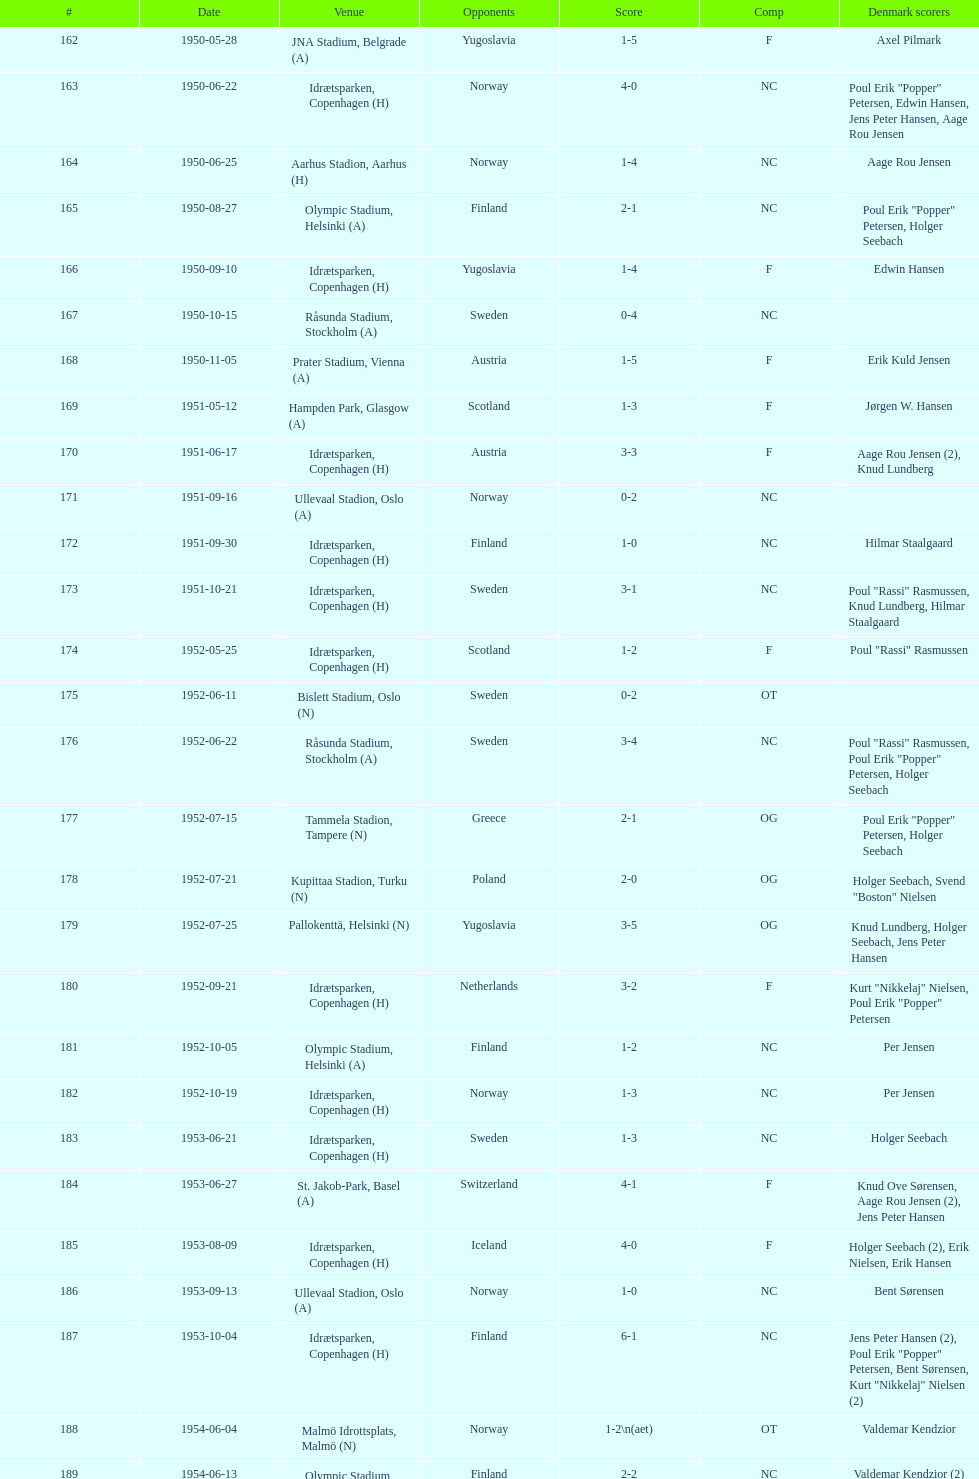Help me parse the entirety of this table. {'header': ['#', 'Date', 'Venue', 'Opponents', 'Score', 'Comp', 'Denmark scorers'], 'rows': [['162', '1950-05-28', 'JNA Stadium, Belgrade (A)', 'Yugoslavia', '1-5', 'F', 'Axel Pilmark'], ['163', '1950-06-22', 'Idrætsparken, Copenhagen (H)', 'Norway', '4-0', 'NC', 'Poul Erik "Popper" Petersen, Edwin Hansen, Jens Peter Hansen, Aage Rou Jensen'], ['164', '1950-06-25', 'Aarhus Stadion, Aarhus (H)', 'Norway', '1-4', 'NC', 'Aage Rou Jensen'], ['165', '1950-08-27', 'Olympic Stadium, Helsinki (A)', 'Finland', '2-1', 'NC', 'Poul Erik "Popper" Petersen, Holger Seebach'], ['166', '1950-09-10', 'Idrætsparken, Copenhagen (H)', 'Yugoslavia', '1-4', 'F', 'Edwin Hansen'], ['167', '1950-10-15', 'Råsunda Stadium, Stockholm (A)', 'Sweden', '0-4', 'NC', ''], ['168', '1950-11-05', 'Prater Stadium, Vienna (A)', 'Austria', '1-5', 'F', 'Erik Kuld Jensen'], ['169', '1951-05-12', 'Hampden Park, Glasgow (A)', 'Scotland', '1-3', 'F', 'Jørgen W. Hansen'], ['170', '1951-06-17', 'Idrætsparken, Copenhagen (H)', 'Austria', '3-3', 'F', 'Aage Rou Jensen (2), Knud Lundberg'], ['171', '1951-09-16', 'Ullevaal Stadion, Oslo (A)', 'Norway', '0-2', 'NC', ''], ['172', '1951-09-30', 'Idrætsparken, Copenhagen (H)', 'Finland', '1-0', 'NC', 'Hilmar Staalgaard'], ['173', '1951-10-21', 'Idrætsparken, Copenhagen (H)', 'Sweden', '3-1', 'NC', 'Poul "Rassi" Rasmussen, Knud Lundberg, Hilmar Staalgaard'], ['174', '1952-05-25', 'Idrætsparken, Copenhagen (H)', 'Scotland', '1-2', 'F', 'Poul "Rassi" Rasmussen'], ['175', '1952-06-11', 'Bislett Stadium, Oslo (N)', 'Sweden', '0-2', 'OT', ''], ['176', '1952-06-22', 'Råsunda Stadium, Stockholm (A)', 'Sweden', '3-4', 'NC', 'Poul "Rassi" Rasmussen, Poul Erik "Popper" Petersen, Holger Seebach'], ['177', '1952-07-15', 'Tammela Stadion, Tampere (N)', 'Greece', '2-1', 'OG', 'Poul Erik "Popper" Petersen, Holger Seebach'], ['178', '1952-07-21', 'Kupittaa Stadion, Turku (N)', 'Poland', '2-0', 'OG', 'Holger Seebach, Svend "Boston" Nielsen'], ['179', '1952-07-25', 'Pallokenttä, Helsinki (N)', 'Yugoslavia', '3-5', 'OG', 'Knud Lundberg, Holger Seebach, Jens Peter Hansen'], ['180', '1952-09-21', 'Idrætsparken, Copenhagen (H)', 'Netherlands', '3-2', 'F', 'Kurt "Nikkelaj" Nielsen, Poul Erik "Popper" Petersen'], ['181', '1952-10-05', 'Olympic Stadium, Helsinki (A)', 'Finland', '1-2', 'NC', 'Per Jensen'], ['182', '1952-10-19', 'Idrætsparken, Copenhagen (H)', 'Norway', '1-3', 'NC', 'Per Jensen'], ['183', '1953-06-21', 'Idrætsparken, Copenhagen (H)', 'Sweden', '1-3', 'NC', 'Holger Seebach'], ['184', '1953-06-27', 'St. Jakob-Park, Basel (A)', 'Switzerland', '4-1', 'F', 'Knud Ove Sørensen, Aage Rou Jensen (2), Jens Peter Hansen'], ['185', '1953-08-09', 'Idrætsparken, Copenhagen (H)', 'Iceland', '4-0', 'F', 'Holger Seebach (2), Erik Nielsen, Erik Hansen'], ['186', '1953-09-13', 'Ullevaal Stadion, Oslo (A)', 'Norway', '1-0', 'NC', 'Bent Sørensen'], ['187', '1953-10-04', 'Idrætsparken, Copenhagen (H)', 'Finland', '6-1', 'NC', 'Jens Peter Hansen (2), Poul Erik "Popper" Petersen, Bent Sørensen, Kurt "Nikkelaj" Nielsen (2)'], ['188', '1954-06-04', 'Malmö Idrottsplats, Malmö (N)', 'Norway', '1-2\\n(aet)', 'OT', 'Valdemar Kendzior'], ['189', '1954-06-13', 'Olympic Stadium, Helsinki (A)', 'Finland', '2-2', 'NC', 'Valdemar Kendzior (2)'], ['190', '1954-09-19', 'Idrætsparken, Copenhagen (H)', 'Switzerland', '1-1', 'F', 'Jørgen Olesen'], ['191', '1954-10-10', 'Råsunda Stadium, Stockholm (A)', 'Sweden', '2-5', 'NC', 'Jens Peter Hansen, Bent Sørensen'], ['192', '1954-10-31', 'Idrætsparken, Copenhagen (H)', 'Norway', '0-1', 'NC', ''], ['193', '1955-03-13', 'Olympic Stadium, Amsterdam (A)', 'Netherlands', '1-1', 'F', 'Vagn Birkeland'], ['194', '1955-05-15', 'Idrætsparken, Copenhagen (H)', 'Hungary', '0-6', 'F', ''], ['195', '1955-06-19', 'Idrætsparken, Copenhagen (H)', 'Finland', '2-1', 'NC', 'Jens Peter Hansen (2)'], ['196', '1955-06-03', 'Melavollur, Reykjavík (A)', 'Iceland', '4-0', 'F', 'Aage Rou Jensen, Jens Peter Hansen, Poul Pedersen (2)'], ['197', '1955-09-11', 'Ullevaal Stadion, Oslo (A)', 'Norway', '1-1', 'NC', 'Jørgen Jacobsen'], ['198', '1955-10-02', 'Idrætsparken, Copenhagen (H)', 'England', '1-5', 'NC', 'Knud Lundberg'], ['199', '1955-10-16', 'Idrætsparken, Copenhagen (H)', 'Sweden', '3-3', 'NC', 'Ove Andersen (2), Knud Lundberg'], ['200', '1956-05-23', 'Dynamo Stadium, Moscow (A)', 'USSR', '1-5', 'F', 'Knud Lundberg'], ['201', '1956-06-24', 'Idrætsparken, Copenhagen (H)', 'Norway', '2-3', 'NC', 'Knud Lundberg, Poul Pedersen'], ['202', '1956-07-01', 'Idrætsparken, Copenhagen (H)', 'USSR', '2-5', 'F', 'Ove Andersen, Aage Rou Jensen'], ['203', '1956-09-16', 'Olympic Stadium, Helsinki (A)', 'Finland', '4-0', 'NC', 'Poul Pedersen, Jørgen Hansen, Ove Andersen (2)'], ['204', '1956-10-03', 'Dalymount Park, Dublin (A)', 'Republic of Ireland', '1-2', 'WCQ', 'Aage Rou Jensen'], ['205', '1956-10-21', 'Råsunda Stadium, Stockholm (A)', 'Sweden', '1-1', 'NC', 'Jens Peter Hansen'], ['206', '1956-11-04', 'Idrætsparken, Copenhagen (H)', 'Netherlands', '2-2', 'F', 'Jørgen Olesen, Knud Lundberg'], ['207', '1956-12-05', 'Molineux, Wolverhampton (A)', 'England', '2-5', 'WCQ', 'Ove Bech Nielsen (2)'], ['208', '1957-05-15', 'Idrætsparken, Copenhagen (H)', 'England', '1-4', 'WCQ', 'John Jensen'], ['209', '1957-05-26', 'Idrætsparken, Copenhagen (H)', 'Bulgaria', '1-1', 'F', 'Aage Rou Jensen'], ['210', '1957-06-18', 'Olympic Stadium, Helsinki (A)', 'Finland', '0-2', 'OT', ''], ['211', '1957-06-19', 'Tammela Stadion, Tampere (N)', 'Norway', '2-0', 'OT', 'Egon Jensen, Jørgen Hansen'], ['212', '1957-06-30', 'Idrætsparken, Copenhagen (H)', 'Sweden', '1-2', 'NC', 'Jens Peter Hansen'], ['213', '1957-07-10', 'Laugardalsvöllur, Reykjavík (A)', 'Iceland', '6-2', 'OT', 'Egon Jensen (3), Poul Pedersen, Jens Peter Hansen (2)'], ['214', '1957-09-22', 'Ullevaal Stadion, Oslo (A)', 'Norway', '2-2', 'NC', 'Poul Pedersen, Peder Kjær'], ['215', '1957-10-02', 'Idrætsparken, Copenhagen (H)', 'Republic of Ireland', '0-2', 'WCQ', ''], ['216', '1957-10-13', 'Idrætsparken, Copenhagen (H)', 'Finland', '3-0', 'NC', 'Finn Alfred Hansen, Ove Bech Nielsen, Mogens Machon'], ['217', '1958-05-15', 'Aarhus Stadion, Aarhus (H)', 'Curaçao', '3-2', 'F', 'Poul Pedersen, Henning Enoksen (2)'], ['218', '1958-05-25', 'Idrætsparken, Copenhagen (H)', 'Poland', '3-2', 'F', 'Jørn Sørensen, Poul Pedersen (2)'], ['219', '1958-06-29', 'Idrætsparken, Copenhagen (H)', 'Norway', '1-2', 'NC', 'Poul Pedersen'], ['220', '1958-09-14', 'Olympic Stadium, Helsinki (A)', 'Finland', '4-1', 'NC', 'Poul Pedersen, Mogens Machon, John Danielsen (2)'], ['221', '1958-09-24', 'Idrætsparken, Copenhagen (H)', 'West Germany', '1-1', 'F', 'Henning Enoksen'], ['222', '1958-10-15', 'Idrætsparken, Copenhagen (H)', 'Netherlands', '1-5', 'F', 'Henning Enoksen'], ['223', '1958-10-26', 'Råsunda Stadium, Stockholm (A)', 'Sweden', '4-4', 'NC', 'Ole Madsen (2), Henning Enoksen, Jørn Sørensen'], ['224', '1959-06-21', 'Idrætsparken, Copenhagen (H)', 'Sweden', '0-6', 'NC', ''], ['225', '1959-06-26', 'Laugardalsvöllur, Reykjavík (A)', 'Iceland', '4-2', 'OGQ', 'Jens Peter Hansen (2), Ole Madsen (2)'], ['226', '1959-07-02', 'Idrætsparken, Copenhagen (H)', 'Norway', '2-1', 'OGQ', 'Henning Enoksen, Ole Madsen'], ['227', '1959-08-18', 'Idrætsparken, Copenhagen (H)', 'Iceland', '1-1', 'OGQ', 'Henning Enoksen'], ['228', '1959-09-13', 'Ullevaal Stadion, Oslo (A)', 'Norway', '4-2', 'OGQ\\nNC', 'Harald Nielsen, Henning Enoksen (2), Poul Pedersen'], ['229', '1959-09-23', 'Idrætsparken, Copenhagen (H)', 'Czechoslovakia', '2-2', 'ENQ', 'Poul Pedersen, Bent Hansen'], ['230', '1959-10-04', 'Idrætsparken, Copenhagen (H)', 'Finland', '4-0', 'NC', 'Harald Nielsen (3), John Kramer'], ['231', '1959-10-18', 'Stadion Za Lužánkami, Brno (A)', 'Czechoslovakia', '1-5', 'ENQ', 'John Kramer'], ['232', '1959-12-02', 'Olympic Stadium, Athens (A)', 'Greece', '3-1', 'F', 'Henning Enoksen (2), Poul Pedersen'], ['233', '1959-12-06', 'Vasil Levski National Stadium, Sofia (A)', 'Bulgaria', '1-2', 'F', 'Henning Enoksen']]} Which venue was listed immediately preceding olympic stadium on the date of august 27, 1950? Aarhus Stadion, Aarhus. 